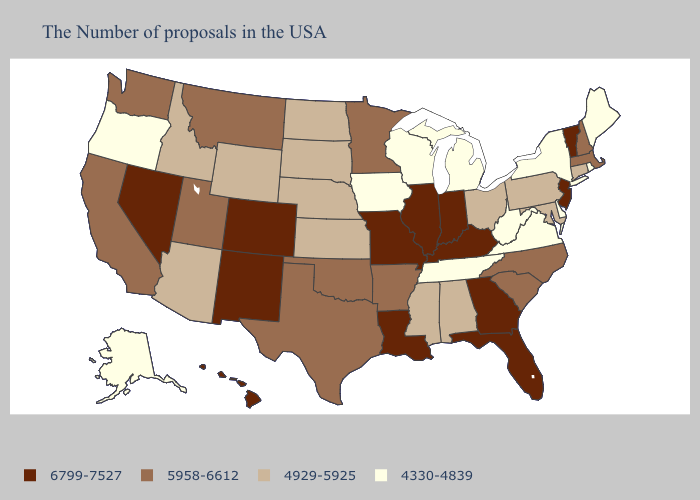Name the states that have a value in the range 6799-7527?
Be succinct. Vermont, New Jersey, Florida, Georgia, Kentucky, Indiana, Illinois, Louisiana, Missouri, Colorado, New Mexico, Nevada, Hawaii. Does Vermont have the lowest value in the Northeast?
Write a very short answer. No. Among the states that border Colorado , does Kansas have the lowest value?
Be succinct. Yes. What is the value of Missouri?
Give a very brief answer. 6799-7527. What is the value of Wisconsin?
Quick response, please. 4330-4839. What is the value of Montana?
Give a very brief answer. 5958-6612. How many symbols are there in the legend?
Answer briefly. 4. What is the value of Texas?
Quick response, please. 5958-6612. Does Georgia have a lower value than Minnesota?
Keep it brief. No. Does the first symbol in the legend represent the smallest category?
Keep it brief. No. What is the lowest value in the South?
Short answer required. 4330-4839. What is the highest value in the USA?
Be succinct. 6799-7527. What is the lowest value in the West?
Give a very brief answer. 4330-4839. Name the states that have a value in the range 4929-5925?
Quick response, please. Connecticut, Maryland, Pennsylvania, Ohio, Alabama, Mississippi, Kansas, Nebraska, South Dakota, North Dakota, Wyoming, Arizona, Idaho. Name the states that have a value in the range 5958-6612?
Quick response, please. Massachusetts, New Hampshire, North Carolina, South Carolina, Arkansas, Minnesota, Oklahoma, Texas, Utah, Montana, California, Washington. 